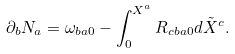<formula> <loc_0><loc_0><loc_500><loc_500>\partial _ { b } N _ { a } = \omega _ { b a 0 } - \int _ { 0 } ^ { X ^ { a } } R _ { c b a 0 } d \tilde { X } ^ { c } .</formula> 